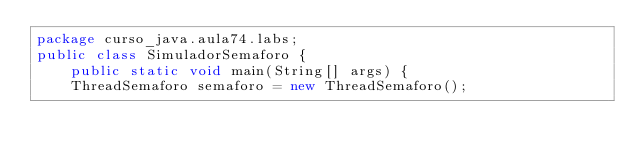Convert code to text. <code><loc_0><loc_0><loc_500><loc_500><_Java_>package curso_java.aula74.labs;
public class SimuladorSemaforo {
    public static void main(String[] args) {
    ThreadSemaforo semaforo = new ThreadSemaforo();		</code> 